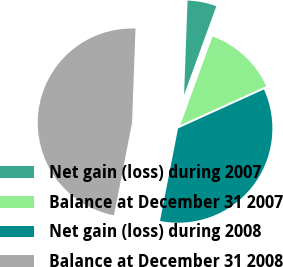<chart> <loc_0><loc_0><loc_500><loc_500><pie_chart><fcel>Net gain (loss) during 2007<fcel>Balance at December 31 2007<fcel>Net gain (loss) during 2008<fcel>Balance at December 31 2008<nl><fcel>4.97%<fcel>12.67%<fcel>34.85%<fcel>47.52%<nl></chart> 